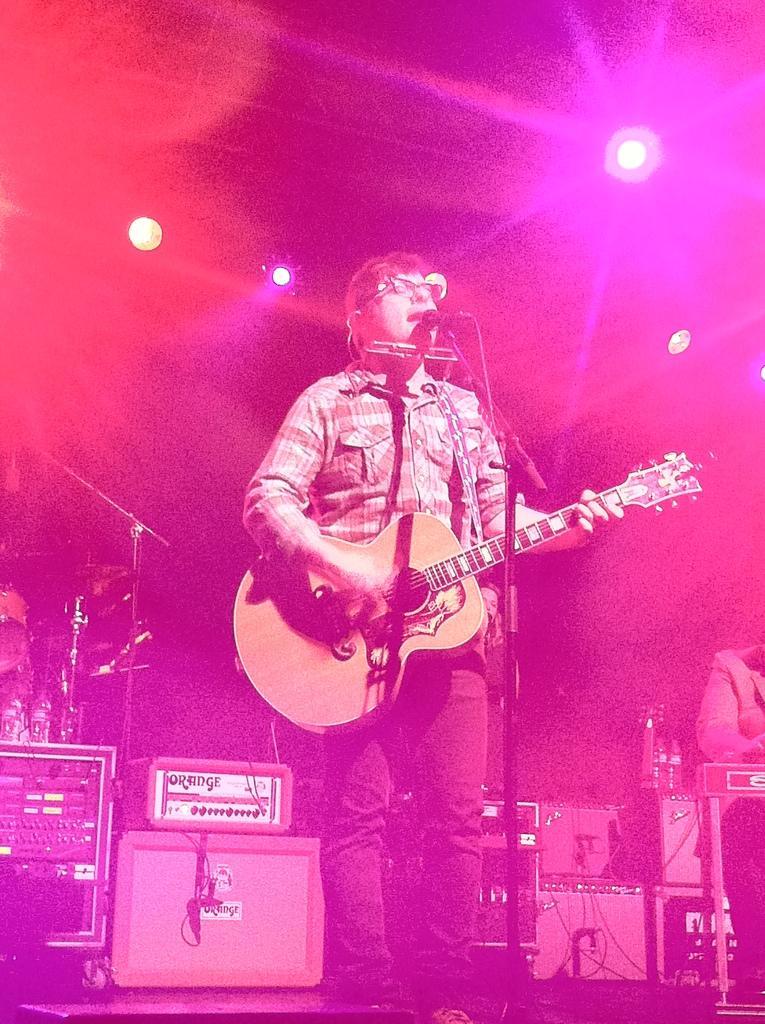Can you describe this image briefly? In this image there is a person wearing shirt playing guitar in front of him there is a microphone and at the background of the image there are some boxes and at the top of the image there are lights. 